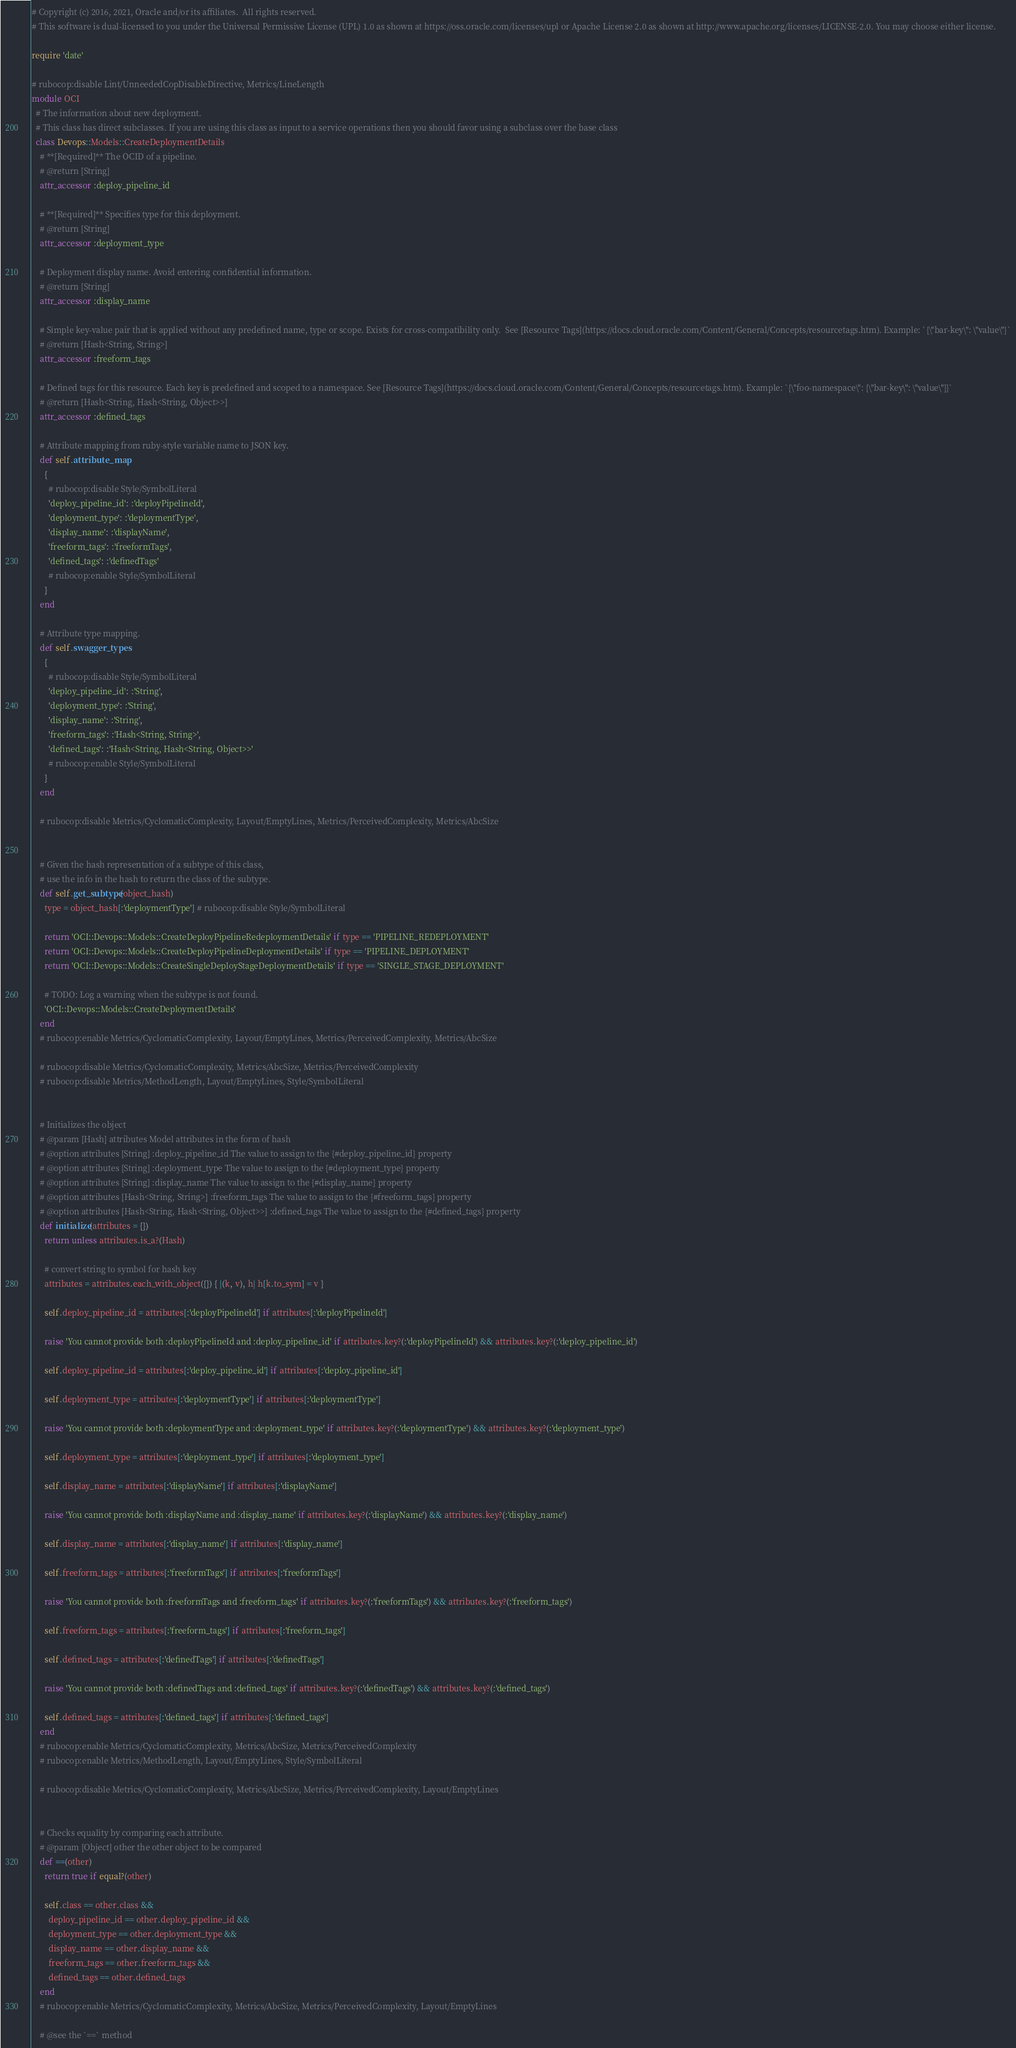<code> <loc_0><loc_0><loc_500><loc_500><_Ruby_># Copyright (c) 2016, 2021, Oracle and/or its affiliates.  All rights reserved.
# This software is dual-licensed to you under the Universal Permissive License (UPL) 1.0 as shown at https://oss.oracle.com/licenses/upl or Apache License 2.0 as shown at http://www.apache.org/licenses/LICENSE-2.0. You may choose either license.

require 'date'

# rubocop:disable Lint/UnneededCopDisableDirective, Metrics/LineLength
module OCI
  # The information about new deployment.
  # This class has direct subclasses. If you are using this class as input to a service operations then you should favor using a subclass over the base class
  class Devops::Models::CreateDeploymentDetails
    # **[Required]** The OCID of a pipeline.
    # @return [String]
    attr_accessor :deploy_pipeline_id

    # **[Required]** Specifies type for this deployment.
    # @return [String]
    attr_accessor :deployment_type

    # Deployment display name. Avoid entering confidential information.
    # @return [String]
    attr_accessor :display_name

    # Simple key-value pair that is applied without any predefined name, type or scope. Exists for cross-compatibility only.  See [Resource Tags](https://docs.cloud.oracle.com/Content/General/Concepts/resourcetags.htm). Example: `{\"bar-key\": \"value\"}`
    # @return [Hash<String, String>]
    attr_accessor :freeform_tags

    # Defined tags for this resource. Each key is predefined and scoped to a namespace. See [Resource Tags](https://docs.cloud.oracle.com/Content/General/Concepts/resourcetags.htm). Example: `{\"foo-namespace\": {\"bar-key\": \"value\"}}`
    # @return [Hash<String, Hash<String, Object>>]
    attr_accessor :defined_tags

    # Attribute mapping from ruby-style variable name to JSON key.
    def self.attribute_map
      {
        # rubocop:disable Style/SymbolLiteral
        'deploy_pipeline_id': :'deployPipelineId',
        'deployment_type': :'deploymentType',
        'display_name': :'displayName',
        'freeform_tags': :'freeformTags',
        'defined_tags': :'definedTags'
        # rubocop:enable Style/SymbolLiteral
      }
    end

    # Attribute type mapping.
    def self.swagger_types
      {
        # rubocop:disable Style/SymbolLiteral
        'deploy_pipeline_id': :'String',
        'deployment_type': :'String',
        'display_name': :'String',
        'freeform_tags': :'Hash<String, String>',
        'defined_tags': :'Hash<String, Hash<String, Object>>'
        # rubocop:enable Style/SymbolLiteral
      }
    end

    # rubocop:disable Metrics/CyclomaticComplexity, Layout/EmptyLines, Metrics/PerceivedComplexity, Metrics/AbcSize


    # Given the hash representation of a subtype of this class,
    # use the info in the hash to return the class of the subtype.
    def self.get_subtype(object_hash)
      type = object_hash[:'deploymentType'] # rubocop:disable Style/SymbolLiteral

      return 'OCI::Devops::Models::CreateDeployPipelineRedeploymentDetails' if type == 'PIPELINE_REDEPLOYMENT'
      return 'OCI::Devops::Models::CreateDeployPipelineDeploymentDetails' if type == 'PIPELINE_DEPLOYMENT'
      return 'OCI::Devops::Models::CreateSingleDeployStageDeploymentDetails' if type == 'SINGLE_STAGE_DEPLOYMENT'

      # TODO: Log a warning when the subtype is not found.
      'OCI::Devops::Models::CreateDeploymentDetails'
    end
    # rubocop:enable Metrics/CyclomaticComplexity, Layout/EmptyLines, Metrics/PerceivedComplexity, Metrics/AbcSize

    # rubocop:disable Metrics/CyclomaticComplexity, Metrics/AbcSize, Metrics/PerceivedComplexity
    # rubocop:disable Metrics/MethodLength, Layout/EmptyLines, Style/SymbolLiteral


    # Initializes the object
    # @param [Hash] attributes Model attributes in the form of hash
    # @option attributes [String] :deploy_pipeline_id The value to assign to the {#deploy_pipeline_id} property
    # @option attributes [String] :deployment_type The value to assign to the {#deployment_type} property
    # @option attributes [String] :display_name The value to assign to the {#display_name} property
    # @option attributes [Hash<String, String>] :freeform_tags The value to assign to the {#freeform_tags} property
    # @option attributes [Hash<String, Hash<String, Object>>] :defined_tags The value to assign to the {#defined_tags} property
    def initialize(attributes = {})
      return unless attributes.is_a?(Hash)

      # convert string to symbol for hash key
      attributes = attributes.each_with_object({}) { |(k, v), h| h[k.to_sym] = v }

      self.deploy_pipeline_id = attributes[:'deployPipelineId'] if attributes[:'deployPipelineId']

      raise 'You cannot provide both :deployPipelineId and :deploy_pipeline_id' if attributes.key?(:'deployPipelineId') && attributes.key?(:'deploy_pipeline_id')

      self.deploy_pipeline_id = attributes[:'deploy_pipeline_id'] if attributes[:'deploy_pipeline_id']

      self.deployment_type = attributes[:'deploymentType'] if attributes[:'deploymentType']

      raise 'You cannot provide both :deploymentType and :deployment_type' if attributes.key?(:'deploymentType') && attributes.key?(:'deployment_type')

      self.deployment_type = attributes[:'deployment_type'] if attributes[:'deployment_type']

      self.display_name = attributes[:'displayName'] if attributes[:'displayName']

      raise 'You cannot provide both :displayName and :display_name' if attributes.key?(:'displayName') && attributes.key?(:'display_name')

      self.display_name = attributes[:'display_name'] if attributes[:'display_name']

      self.freeform_tags = attributes[:'freeformTags'] if attributes[:'freeformTags']

      raise 'You cannot provide both :freeformTags and :freeform_tags' if attributes.key?(:'freeformTags') && attributes.key?(:'freeform_tags')

      self.freeform_tags = attributes[:'freeform_tags'] if attributes[:'freeform_tags']

      self.defined_tags = attributes[:'definedTags'] if attributes[:'definedTags']

      raise 'You cannot provide both :definedTags and :defined_tags' if attributes.key?(:'definedTags') && attributes.key?(:'defined_tags')

      self.defined_tags = attributes[:'defined_tags'] if attributes[:'defined_tags']
    end
    # rubocop:enable Metrics/CyclomaticComplexity, Metrics/AbcSize, Metrics/PerceivedComplexity
    # rubocop:enable Metrics/MethodLength, Layout/EmptyLines, Style/SymbolLiteral

    # rubocop:disable Metrics/CyclomaticComplexity, Metrics/AbcSize, Metrics/PerceivedComplexity, Layout/EmptyLines


    # Checks equality by comparing each attribute.
    # @param [Object] other the other object to be compared
    def ==(other)
      return true if equal?(other)

      self.class == other.class &&
        deploy_pipeline_id == other.deploy_pipeline_id &&
        deployment_type == other.deployment_type &&
        display_name == other.display_name &&
        freeform_tags == other.freeform_tags &&
        defined_tags == other.defined_tags
    end
    # rubocop:enable Metrics/CyclomaticComplexity, Metrics/AbcSize, Metrics/PerceivedComplexity, Layout/EmptyLines

    # @see the `==` method</code> 